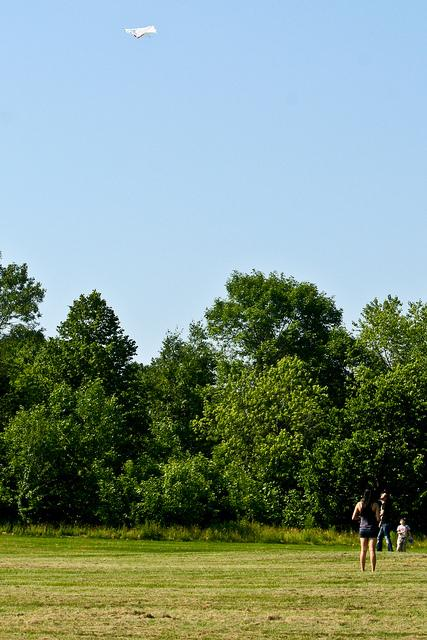What are the people standing in front of? trees 